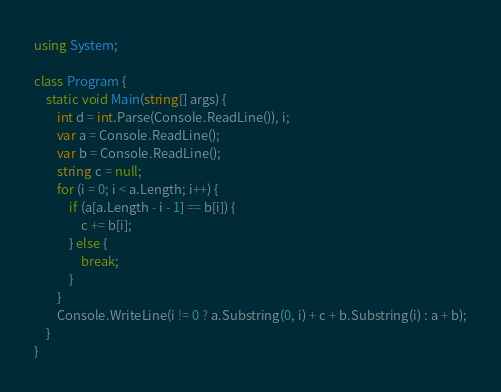<code> <loc_0><loc_0><loc_500><loc_500><_C#_>using System;

class Program {
    static void Main(string[] args) {
        int d = int.Parse(Console.ReadLine()), i;
        var a = Console.ReadLine();
        var b = Console.ReadLine();
        string c = null;
        for (i = 0; i < a.Length; i++) {
            if (a[a.Length - i - 1] == b[i]) {
                c += b[i];
            } else {
                break;
            }
        }
        Console.WriteLine(i != 0 ? a.Substring(0, i) + c + b.Substring(i) : a + b);
    }
}</code> 